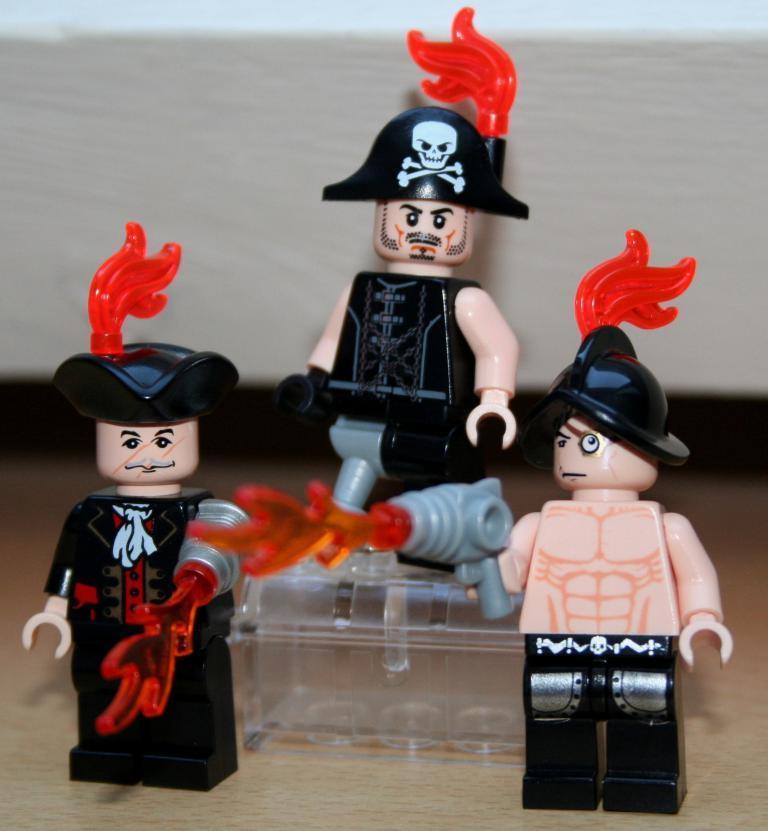Please provide a concise description of this image. Here we can see Lego city toys. There are two toys standing on the floor and behind them other toy is standing on a platform. In the background we can see a platform. 